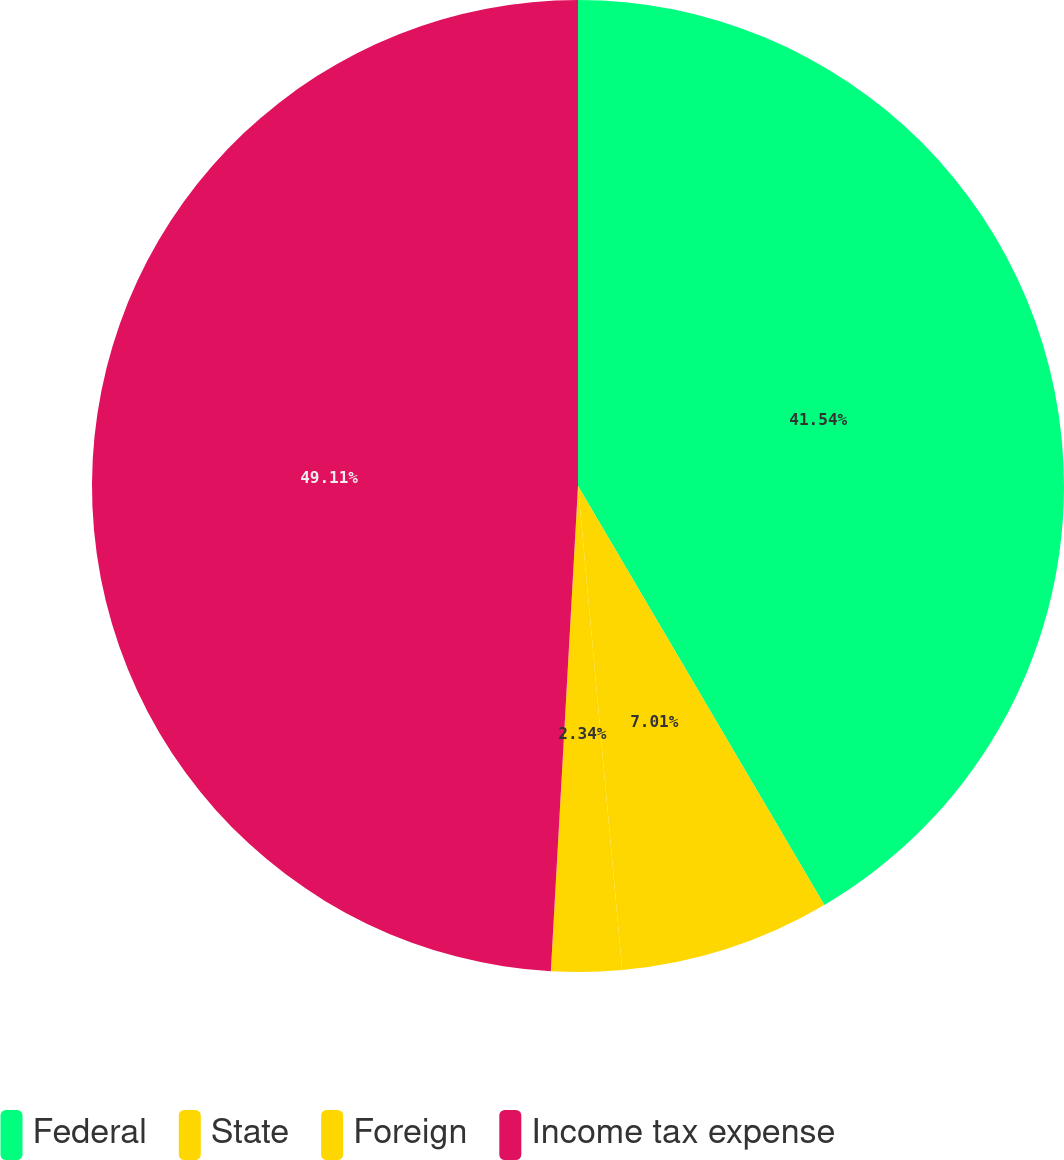Convert chart. <chart><loc_0><loc_0><loc_500><loc_500><pie_chart><fcel>Federal<fcel>State<fcel>Foreign<fcel>Income tax expense<nl><fcel>41.54%<fcel>7.01%<fcel>2.34%<fcel>49.11%<nl></chart> 